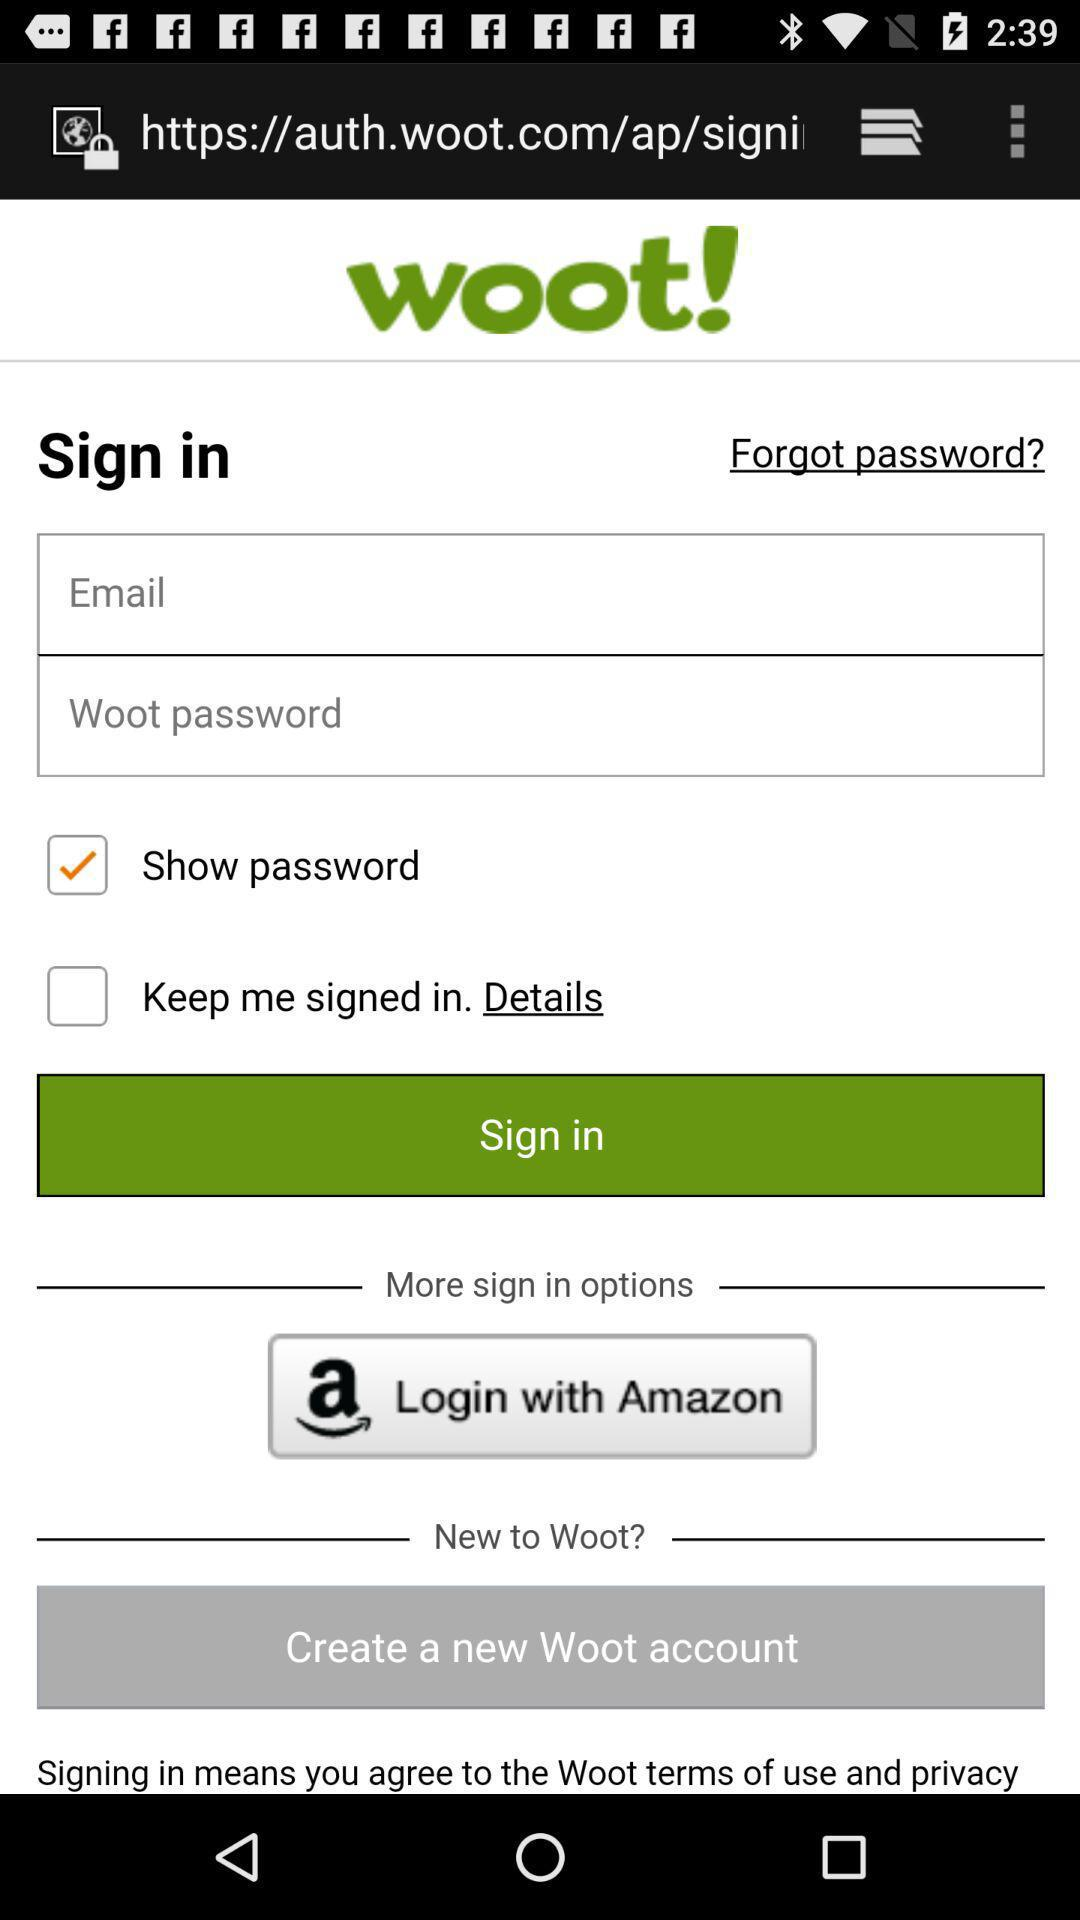What are the different options for signing in? The different options for signing in are "Email" and "Amazon". 